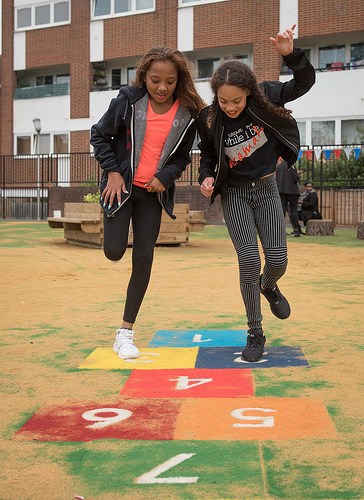<image>
Is the kid to the left of the kid? Yes. From this viewpoint, the kid is positioned to the left side relative to the kid. Is there a four square in front of the three square? Yes. The four square is positioned in front of the three square, appearing closer to the camera viewpoint. 